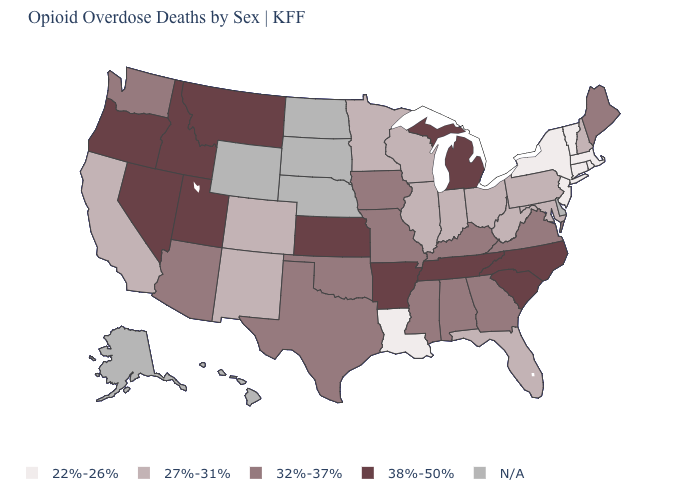What is the value of Arizona?
Write a very short answer. 32%-37%. Is the legend a continuous bar?
Short answer required. No. What is the value of Maryland?
Keep it brief. 27%-31%. What is the value of Nebraska?
Give a very brief answer. N/A. What is the value of North Carolina?
Be succinct. 38%-50%. Does the first symbol in the legend represent the smallest category?
Short answer required. Yes. What is the lowest value in states that border Pennsylvania?
Keep it brief. 22%-26%. What is the value of Kansas?
Concise answer only. 38%-50%. What is the lowest value in the MidWest?
Give a very brief answer. 27%-31%. Does the first symbol in the legend represent the smallest category?
Answer briefly. Yes. What is the value of Connecticut?
Answer briefly. 22%-26%. Which states have the lowest value in the USA?
Be succinct. Connecticut, Louisiana, Massachusetts, New Jersey, New York, Rhode Island, Vermont. What is the lowest value in states that border Utah?
Answer briefly. 27%-31%. 